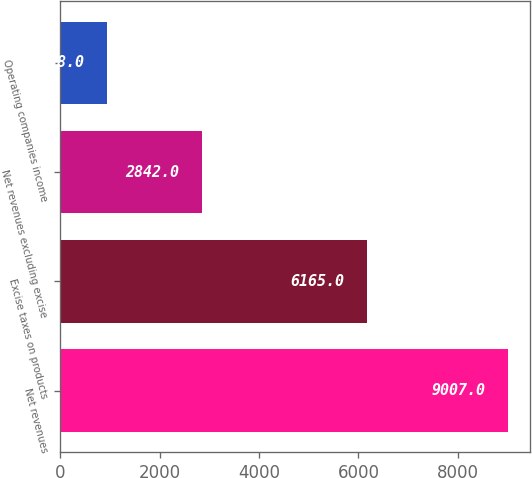Convert chart. <chart><loc_0><loc_0><loc_500><loc_500><bar_chart><fcel>Net revenues<fcel>Excise taxes on products<fcel>Net revenues excluding excise<fcel>Operating companies income<nl><fcel>9007<fcel>6165<fcel>2842<fcel>938<nl></chart> 